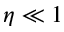<formula> <loc_0><loc_0><loc_500><loc_500>\eta \ll 1</formula> 